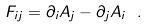Convert formula to latex. <formula><loc_0><loc_0><loc_500><loc_500>F _ { i j } = \partial _ { i } A _ { j } - \partial _ { j } A _ { i } \ .</formula> 